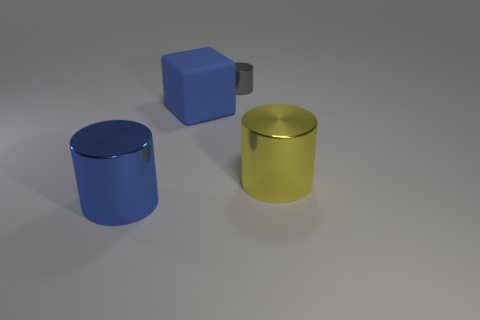Add 4 yellow objects. How many objects exist? 8 Subtract all cubes. How many objects are left? 3 Subtract all blue rubber cubes. Subtract all small metal cylinders. How many objects are left? 2 Add 2 blue blocks. How many blue blocks are left? 3 Add 1 large green shiny cylinders. How many large green shiny cylinders exist? 1 Subtract 0 purple cubes. How many objects are left? 4 